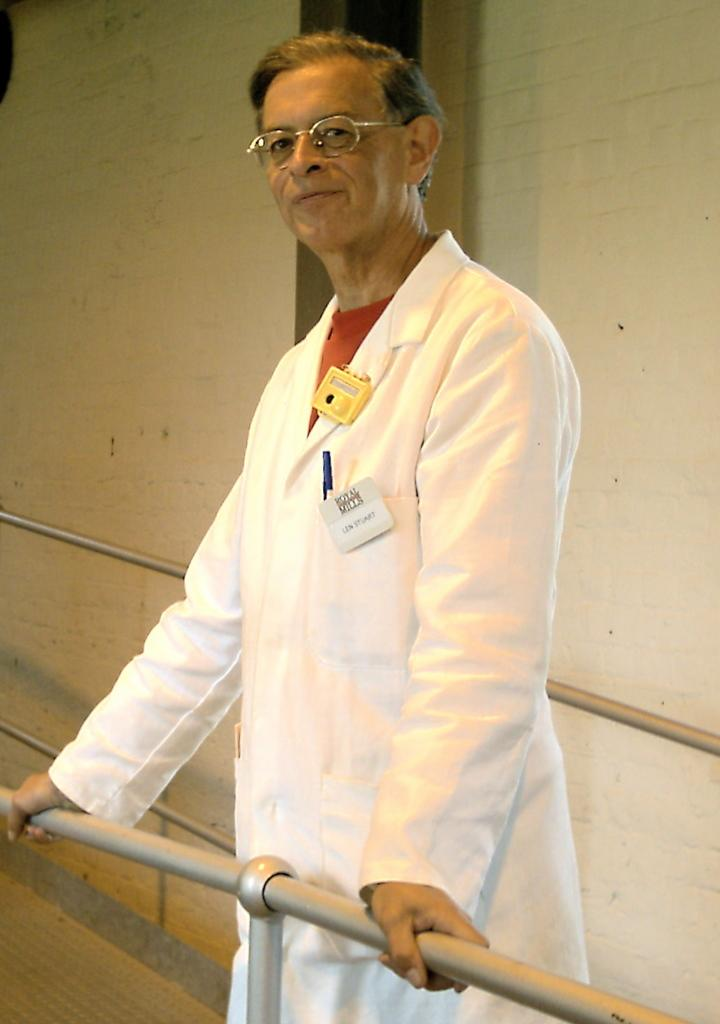What is the person in the image doing? The person is standing in the image and holding a grill. What can be seen in the background of the image? There is a wall in the background of the image. What type of club is the person using to grill in the image? There is no club present in the image; the person is holding a grill. Where can you buy the ingredients for the food being grilled in the image? The image does not show a market or any indication of where the ingredients were purchased. 